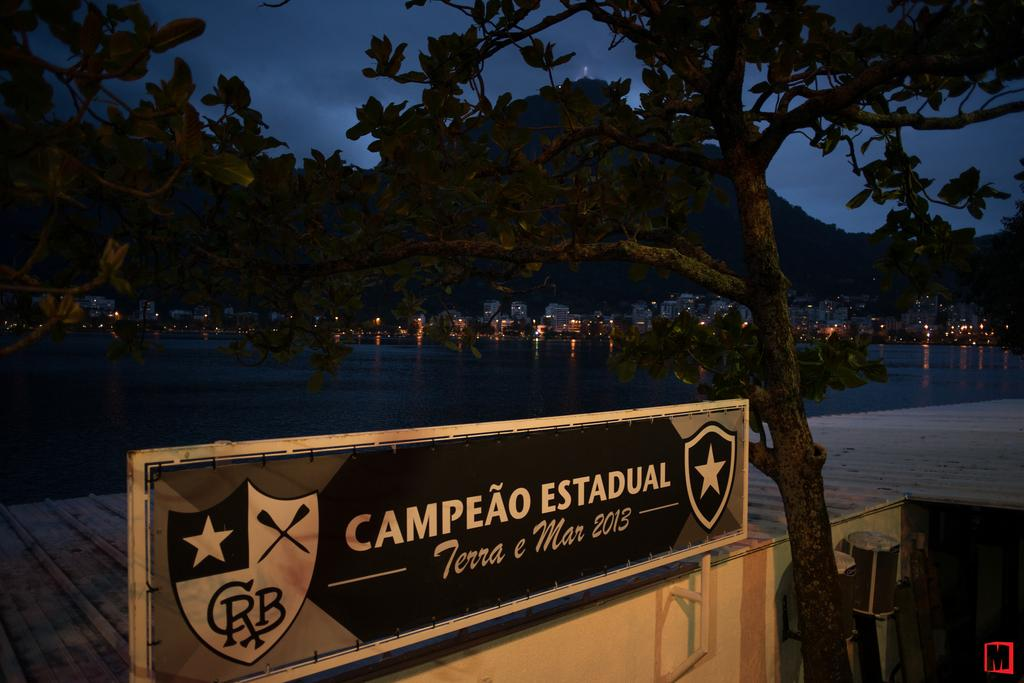What can be seen in the sky in the image? The sky with clouds is visible in the image. What type of natural features are present in the image? There are hills and trees in the image. What type of man-made structures can be seen in the image? Buildings are visible in the image. What type of infrastructure is present in the image? A walkway bridge is in the image. What type of signage is present in the image? There is a name board in the image. What advice does the grandfather give on the arch in the image? There is no grandfather or arch present in the image. What statement is written on the arch in the image? There is no arch present in the image, so no statement can be read. 